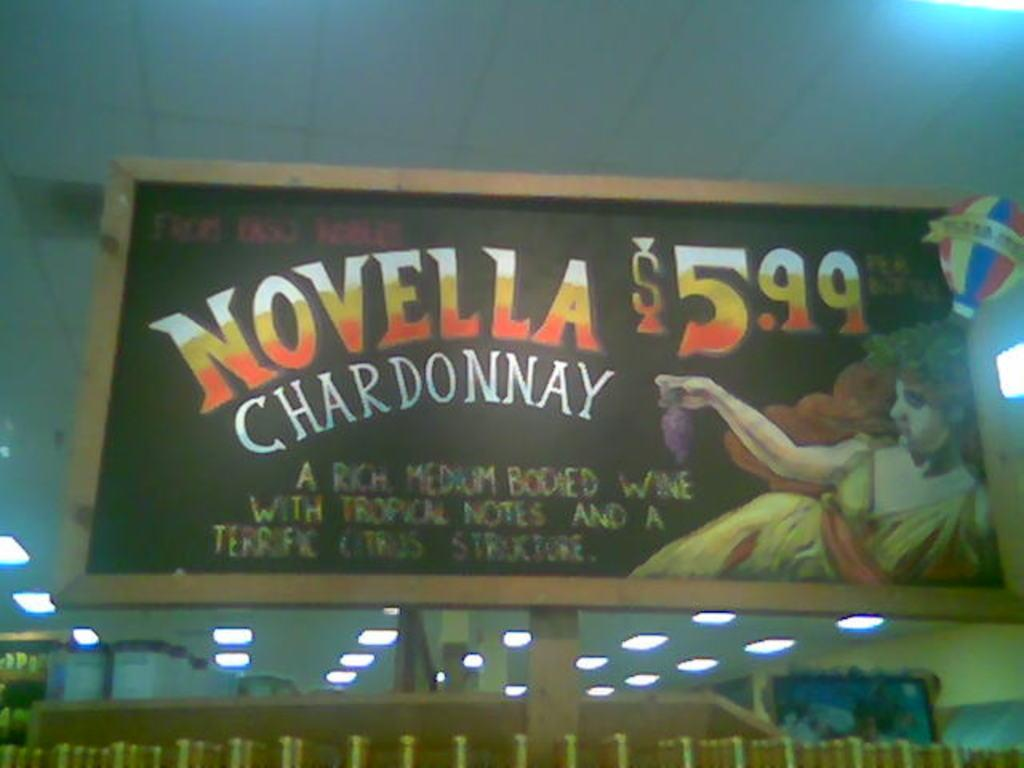<image>
Relay a brief, clear account of the picture shown. An advertisement for Novella Chardonnay written in chalk. 